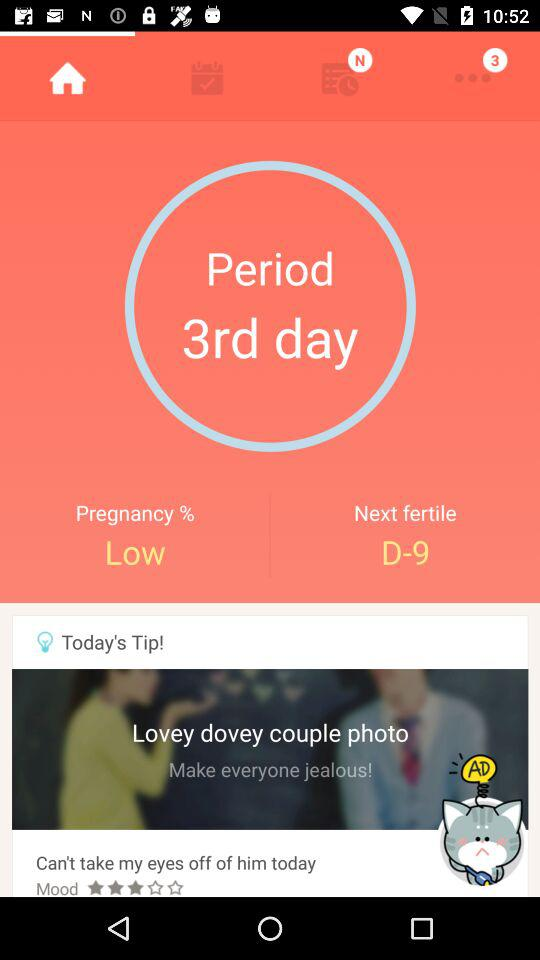How many days are left until the next fertile day?
Answer the question using a single word or phrase. 9 